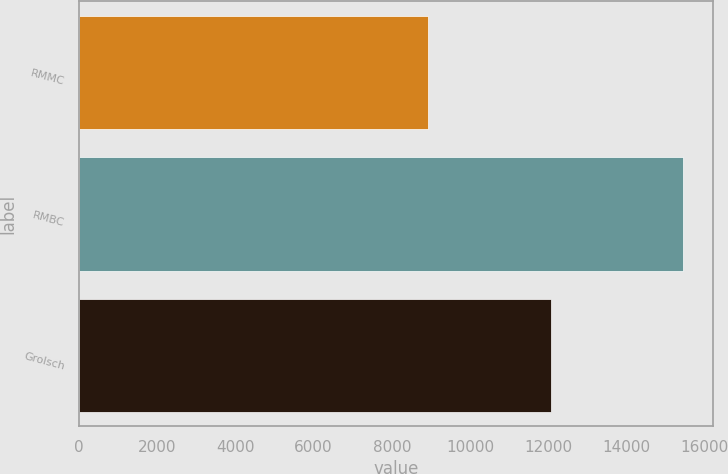Convert chart. <chart><loc_0><loc_0><loc_500><loc_500><bar_chart><fcel>RMMC<fcel>RMBC<fcel>Grolsch<nl><fcel>8925<fcel>15438<fcel>12083<nl></chart> 